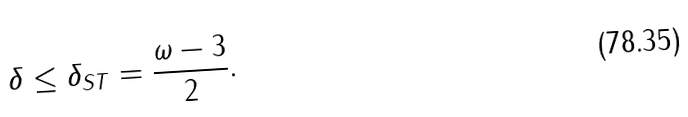<formula> <loc_0><loc_0><loc_500><loc_500>\delta \leq \delta _ { S T } = \frac { \omega - 3 } { 2 } .</formula> 